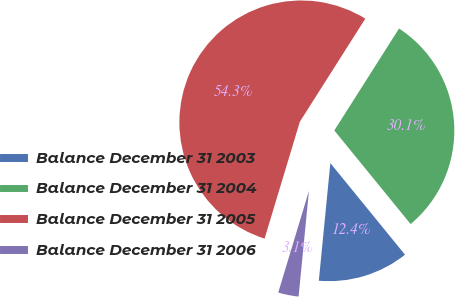Convert chart to OTSL. <chart><loc_0><loc_0><loc_500><loc_500><pie_chart><fcel>Balance December 31 2003<fcel>Balance December 31 2004<fcel>Balance December 31 2005<fcel>Balance December 31 2006<nl><fcel>12.44%<fcel>30.11%<fcel>54.34%<fcel>3.11%<nl></chart> 